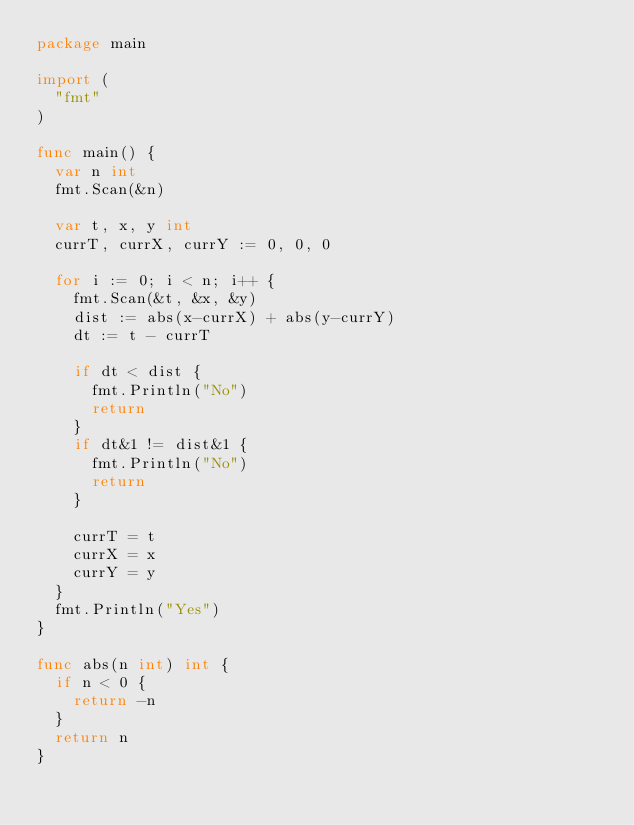<code> <loc_0><loc_0><loc_500><loc_500><_Go_>package main

import (
	"fmt"
)

func main() {
	var n int
	fmt.Scan(&n)

	var t, x, y int
	currT, currX, currY := 0, 0, 0

	for i := 0; i < n; i++ {
		fmt.Scan(&t, &x, &y)
		dist := abs(x-currX) + abs(y-currY)
		dt := t - currT

		if dt < dist {
			fmt.Println("No")
			return
		}
		if dt&1 != dist&1 {
			fmt.Println("No")
			return
		}

		currT = t
		currX = x
		currY = y
	}
	fmt.Println("Yes")
}

func abs(n int) int {
	if n < 0 {
		return -n
	}
	return n
}
</code> 